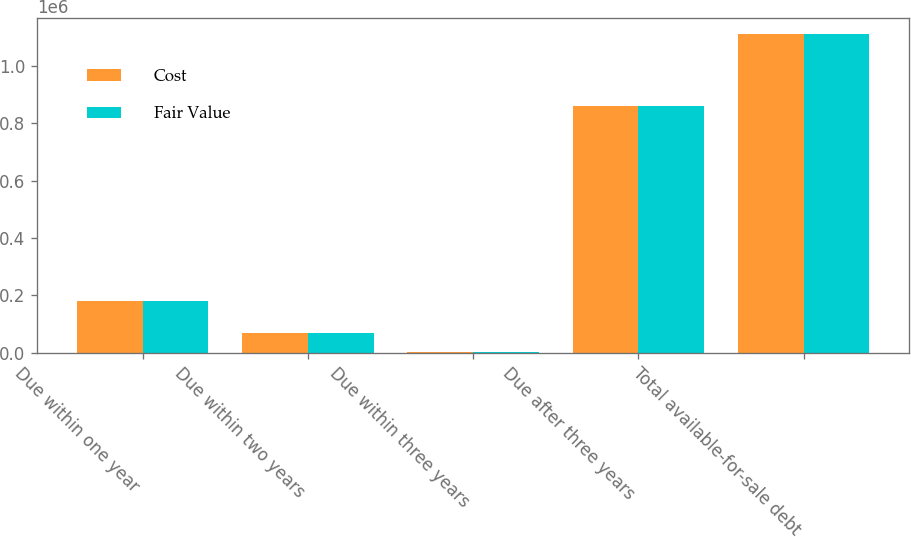Convert chart. <chart><loc_0><loc_0><loc_500><loc_500><stacked_bar_chart><ecel><fcel>Due within one year<fcel>Due within two years<fcel>Due within three years<fcel>Due after three years<fcel>Total available-for-sale debt<nl><fcel>Cost<fcel>179266<fcel>68108<fcel>3133<fcel>861877<fcel>1.11238e+06<nl><fcel>Fair Value<fcel>178856<fcel>67941<fcel>3124<fcel>861698<fcel>1.11162e+06<nl></chart> 